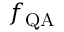<formula> <loc_0><loc_0><loc_500><loc_500>f _ { Q A }</formula> 